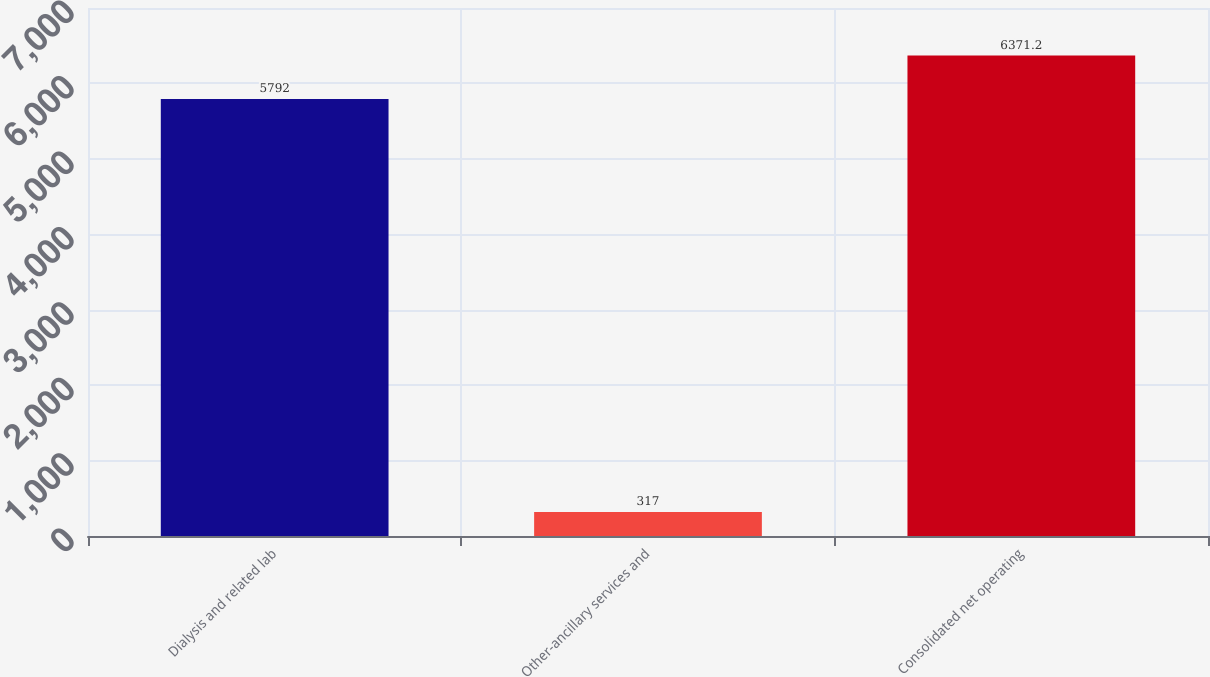<chart> <loc_0><loc_0><loc_500><loc_500><bar_chart><fcel>Dialysis and related lab<fcel>Other-ancillary services and<fcel>Consolidated net operating<nl><fcel>5792<fcel>317<fcel>6371.2<nl></chart> 